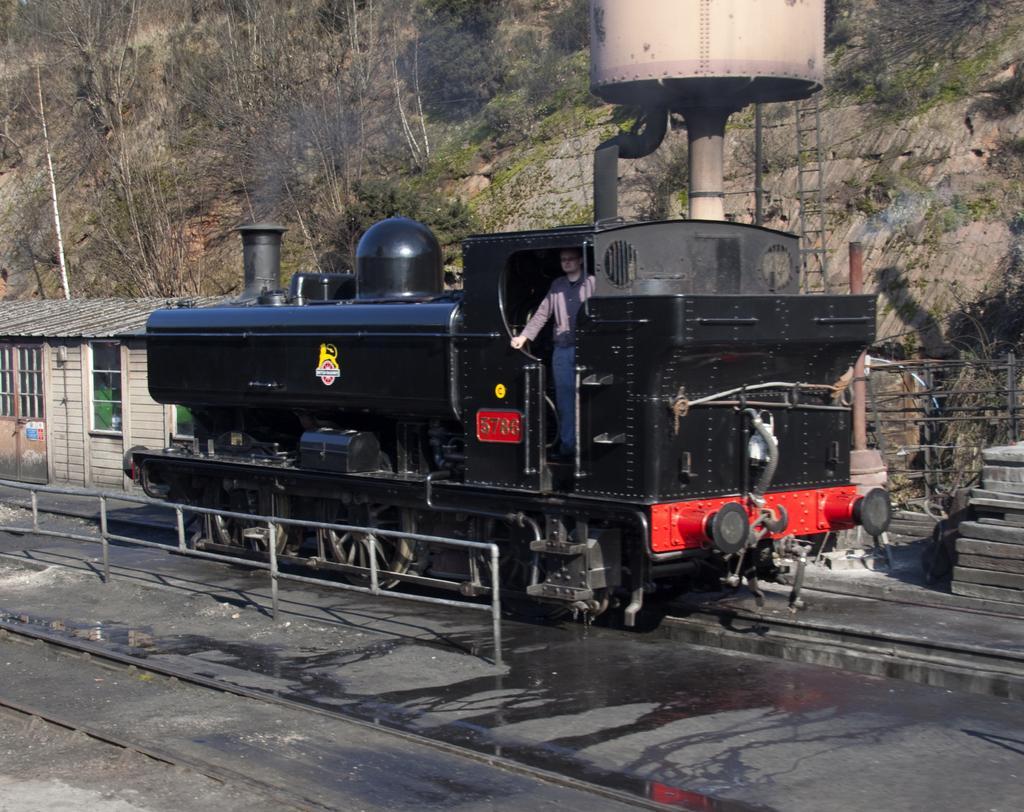In one or two sentences, can you explain what this image depicts? In this image we can see a train engine on the railway track. Behind the engine water tank,fencing, mountains with dry trees and house are there. Left bottom of the image fencing and railway tracks are there. 